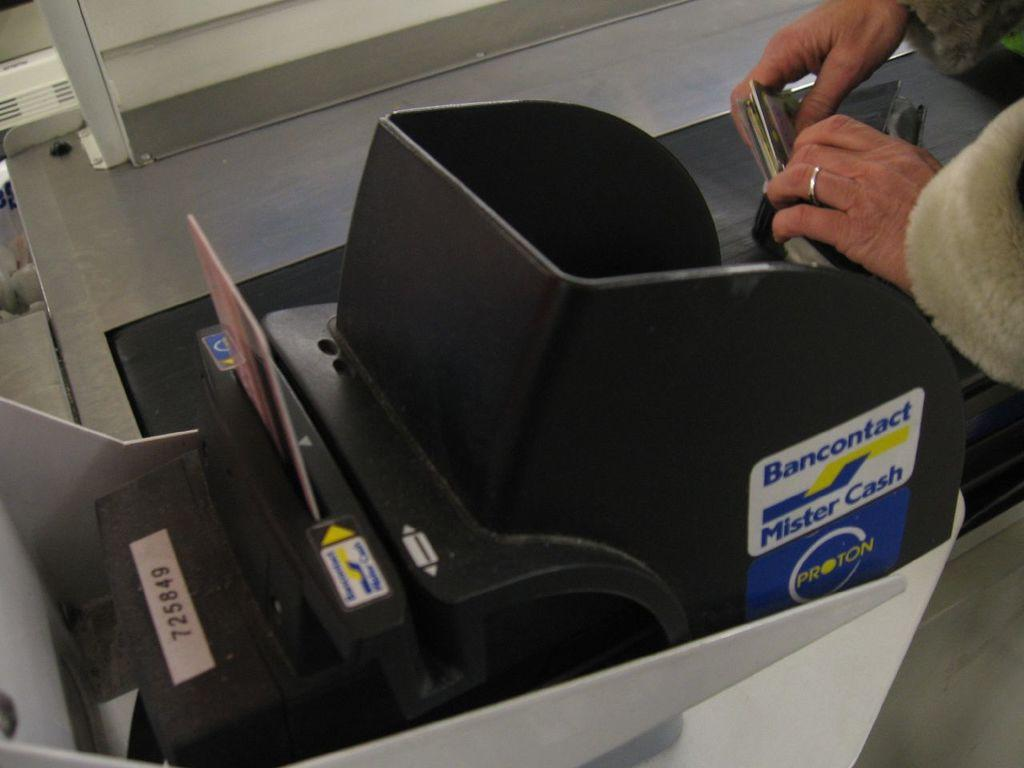What is the main object in the image? There is a machine in the image. Are there any decorations or markings on the machine? Yes, the machine has stickers on it. What else can be seen in the image besides the machine? There is a card in the image. Can you describe the person's hands in the image? A person's hands holding objects are visible in the top right corner of the image. What type of objects can be seen in the background of the image? Metal objects are present in the background of the image. What type of song is the pig singing in the image? There is no pig or song present in the image. 